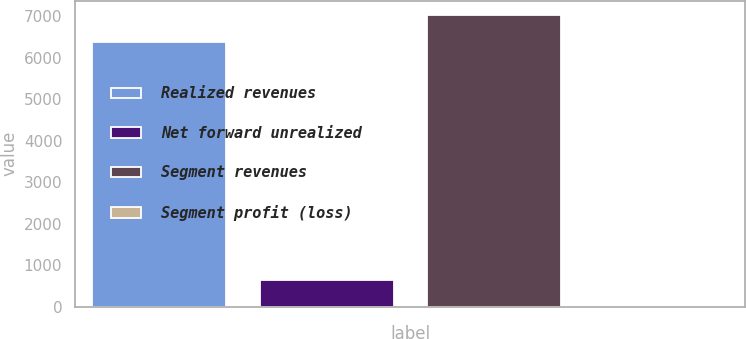Convert chart. <chart><loc_0><loc_0><loc_500><loc_500><bar_chart><fcel>Realized revenues<fcel>Net forward unrealized<fcel>Segment revenues<fcel>Segment profit (loss)<nl><fcel>6385<fcel>643.9<fcel>7025.9<fcel>3<nl></chart> 